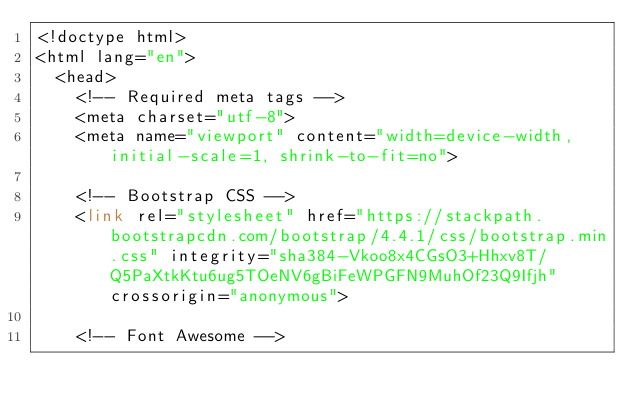Convert code to text. <code><loc_0><loc_0><loc_500><loc_500><_PHP_><!doctype html>
<html lang="en">
  <head>
    <!-- Required meta tags -->
    <meta charset="utf-8">
    <meta name="viewport" content="width=device-width, initial-scale=1, shrink-to-fit=no">

    <!-- Bootstrap CSS -->
    <link rel="stylesheet" href="https://stackpath.bootstrapcdn.com/bootstrap/4.4.1/css/bootstrap.min.css" integrity="sha384-Vkoo8x4CGsO3+Hhxv8T/Q5PaXtkKtu6ug5TOeNV6gBiFeWPGFN9MuhOf23Q9Ifjh" crossorigin="anonymous">

    <!-- Font Awesome --></code> 